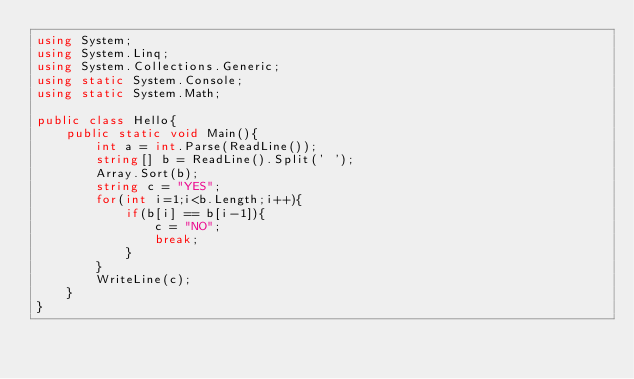Convert code to text. <code><loc_0><loc_0><loc_500><loc_500><_C#_>using System;
using System.Linq;
using System.Collections.Generic;
using static System.Console;
using static System.Math;
 
public class Hello{
    public static void Main(){
        int a = int.Parse(ReadLine());
        string[] b = ReadLine().Split(' ');
        Array.Sort(b);
        string c = "YES";
        for(int i=1;i<b.Length;i++){
            if(b[i] == b[i-1]){
                c = "NO";
                break;
            }
        }
        WriteLine(c);
    }
}
</code> 